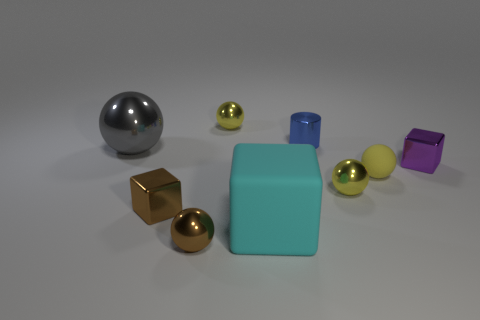There is a shiny thing to the right of the yellow rubber sphere; what is its shape?
Ensure brevity in your answer.  Cube. Are there any tiny brown blocks that have the same material as the tiny brown ball?
Ensure brevity in your answer.  Yes. There is a tiny shiny ball that is behind the tiny yellow rubber object; does it have the same color as the tiny matte sphere?
Give a very brief answer. Yes. How big is the gray sphere?
Offer a terse response. Large. There is a yellow metallic sphere that is in front of the yellow metal object behind the purple block; is there a small blue shiny thing that is in front of it?
Keep it short and to the point. No. What number of things are in front of the big cyan matte block?
Offer a terse response. 1. How many small metallic objects have the same color as the tiny rubber thing?
Your response must be concise. 2. What number of things are spheres that are behind the small blue cylinder or tiny shiny objects to the right of the brown sphere?
Your answer should be compact. 4. Is the number of matte cylinders greater than the number of brown cubes?
Your answer should be compact. No. There is a rubber object that is to the right of the big cyan thing; what is its color?
Keep it short and to the point. Yellow. 